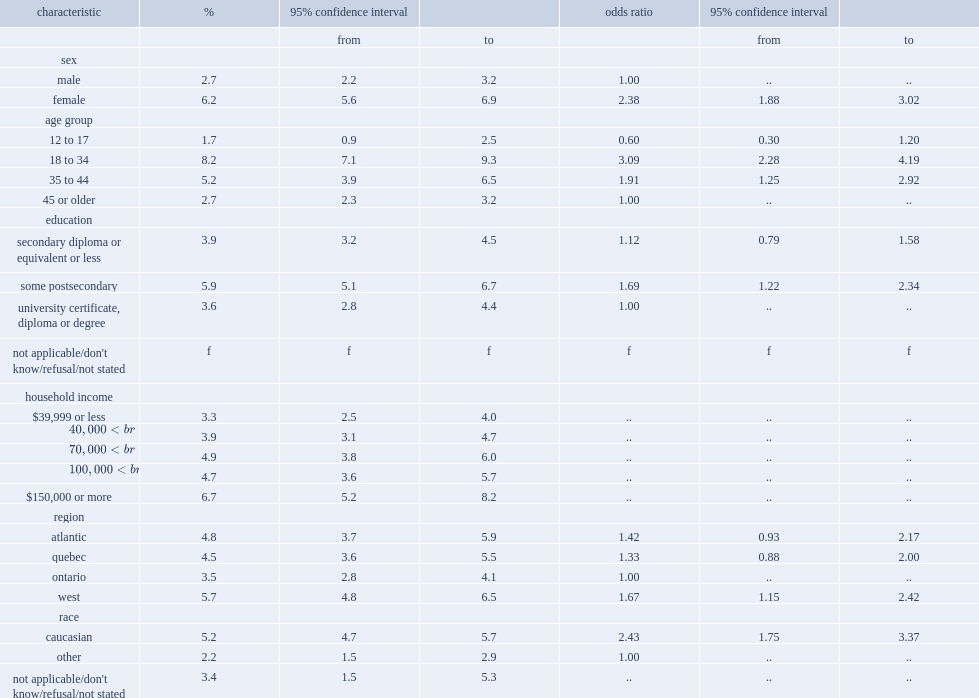Which sex had a higher percentage of the prevalence of in door tannning,males or females? Female. Which age group had the highest prevalence? 18 to 34. Which age group had the highest odds? 18 to 34. How many times did 35 to 44 year olds have more than the odds of using tanning equipment compared with individuals aged 45 or older? 1.925926. What was the prevalence of indoor tanning among people with "some postsecondary (certificate/diploma)"? 5.9. What was the prevalence of indoor tanning among people with "university certificate, diploma or degree"? 3.6. What was the prevalence of indoor tanning among people with "secondary graduation or less"? 3.9. Which education group of people had higher odds of using tanning equipment, people with "some postsecondary (certificate/diploma)" or university graduates? Some postsecondary. Which region had a higher odds of using among residents, ontario residents or western canada? West. 